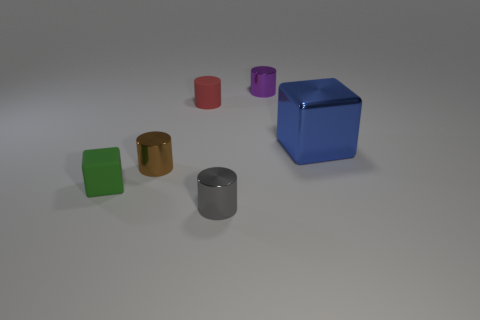Is the material of the cylinder that is behind the red rubber thing the same as the big cube?
Keep it short and to the point. Yes. How many large purple cylinders have the same material as the brown cylinder?
Offer a very short reply. 0. Are there more small things behind the small block than small red cylinders?
Give a very brief answer. Yes. Is there another green thing of the same shape as the big shiny object?
Your answer should be very brief. Yes. What number of things are either yellow things or blue metal blocks?
Keep it short and to the point. 1. How many tiny purple cylinders are right of the rubber thing right of the matte object left of the small red thing?
Your answer should be compact. 1. What material is the green object that is the same shape as the blue object?
Provide a succinct answer. Rubber. There is a cylinder that is behind the big blue object and in front of the purple metallic object; what material is it?
Your answer should be very brief. Rubber. Is the number of big metal blocks on the right side of the large metal cube less than the number of small metallic things on the left side of the red cylinder?
Give a very brief answer. Yes. How many other things are there of the same size as the blue cube?
Offer a very short reply. 0. 